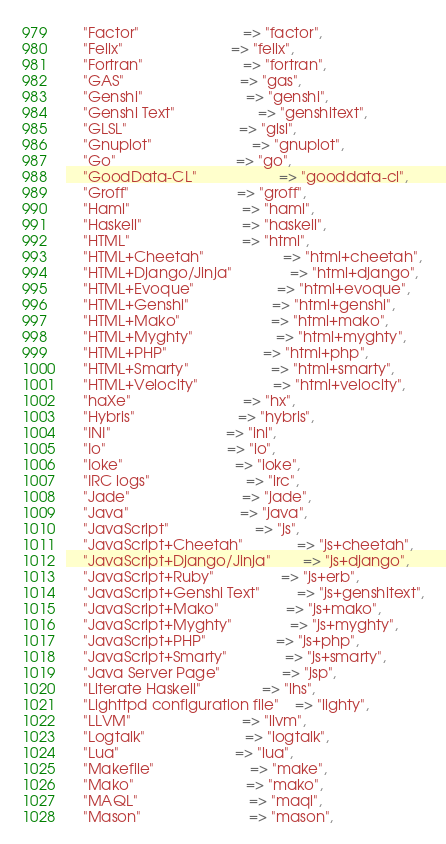Convert code to text. <code><loc_0><loc_0><loc_500><loc_500><_Perl_>    "Factor"                         => "factor",
    "Felix"                          => "felix",
    "Fortran"                        => "fortran",
    "GAS"                            => "gas",
    "Genshi"                         => "genshi",
    "Genshi Text"                    => "genshitext",
    "GLSL"                           => "glsl",
    "Gnuplot"                        => "gnuplot",
    "Go"                             => "go",
    "GoodData-CL"                    => "gooddata-cl",
    "Groff"                          => "groff",
    "Haml"                           => "haml",
    "Haskell"                        => "haskell",
    "HTML"                           => "html",
    "HTML+Cheetah"                   => "html+cheetah",
    "HTML+Django/Jinja"              => "html+django",
    "HTML+Evoque"                    => "html+evoque",
    "HTML+Genshi"                    => "html+genshi",
    "HTML+Mako"                      => "html+mako",
    "HTML+Myghty"                    => "html+myghty",
    "HTML+PHP"                       => "html+php",
    "HTML+Smarty"                    => "html+smarty",
    "HTML+Velocity"                  => "html+velocity",
    "haXe"                           => "hx",
    "Hybris"                         => "hybris",
    "INI"                            => "ini",
    "Io"                             => "io",
    "Ioke"                           => "ioke",
    "IRC logs"                       => "irc",
    "Jade"                           => "jade",
    "Java"                           => "java",
    "JavaScript"                     => "js",
    "JavaScript+Cheetah"             => "js+cheetah",
    "JavaScript+Django/Jinja"        => "js+django",
    "JavaScript+Ruby"                => "js+erb",
    "JavaScript+Genshi Text"         => "js+genshitext",
    "JavaScript+Mako"                => "js+mako",
    "JavaScript+Myghty"              => "js+myghty",
    "JavaScript+PHP"                 => "js+php",
    "JavaScript+Smarty"              => "js+smarty",
    "Java Server Page"               => "jsp",
    "Literate Haskell"               => "lhs",
    "Lighttpd configuration file"    => "lighty",
    "LLVM"                           => "llvm",
    "Logtalk"                        => "logtalk",
    "Lua"                            => "lua",
    "Makefile"                       => "make",
    "Mako"                           => "mako",
    "MAQL"                           => "maql",
    "Mason"                          => "mason",</code> 